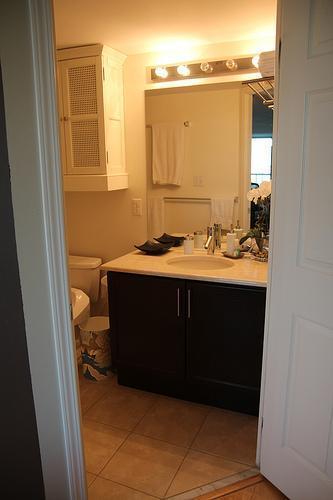How many handles are on the cabinets?
Give a very brief answer. 2. How many toilets are shown?
Give a very brief answer. 1. 